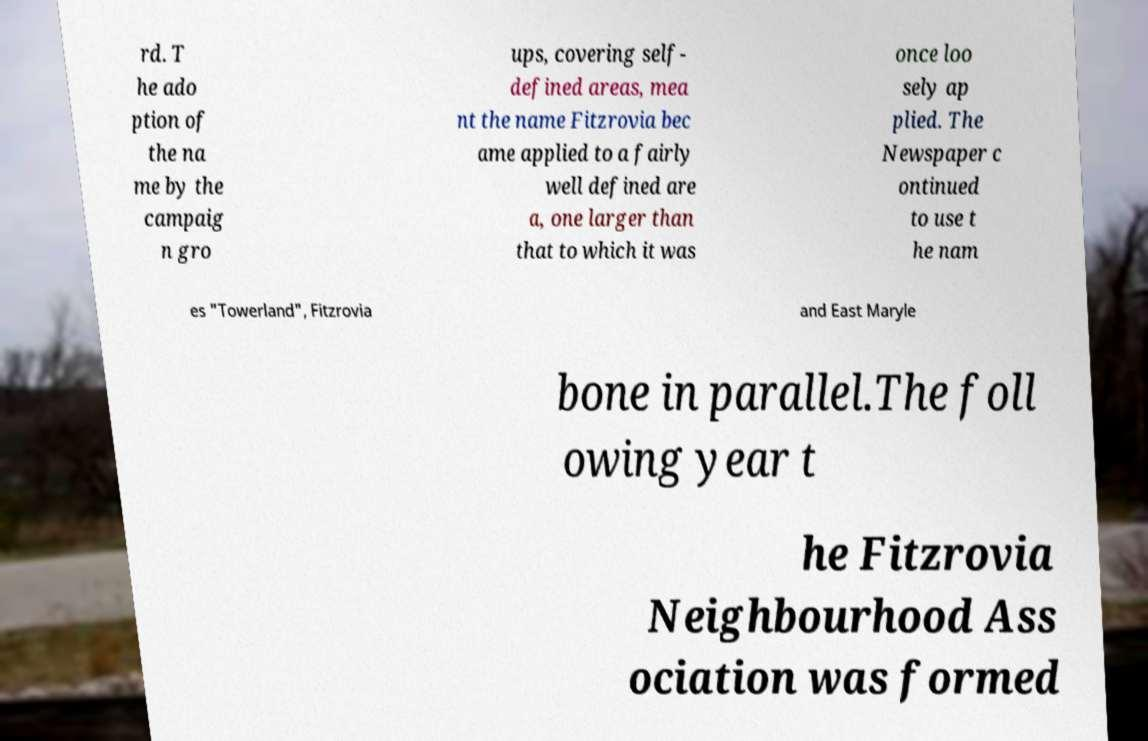Can you accurately transcribe the text from the provided image for me? rd. T he ado ption of the na me by the campaig n gro ups, covering self- defined areas, mea nt the name Fitzrovia bec ame applied to a fairly well defined are a, one larger than that to which it was once loo sely ap plied. The Newspaper c ontinued to use t he nam es "Towerland", Fitzrovia and East Maryle bone in parallel.The foll owing year t he Fitzrovia Neighbourhood Ass ociation was formed 